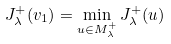<formula> <loc_0><loc_0><loc_500><loc_500>J _ { \lambda } ^ { + } ( v _ { 1 } ) = \min _ { u \in M _ { \lambda } ^ { + } } J _ { \lambda } ^ { + } ( u )</formula> 